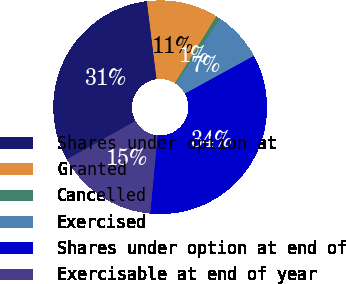Convert chart. <chart><loc_0><loc_0><loc_500><loc_500><pie_chart><fcel>Shares under option at<fcel>Granted<fcel>Cancelled<fcel>Exercised<fcel>Shares under option at end of<fcel>Exercisable at end of year<nl><fcel>31.16%<fcel>10.79%<fcel>0.71%<fcel>7.5%<fcel>34.45%<fcel>15.4%<nl></chart> 